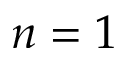Convert formula to latex. <formula><loc_0><loc_0><loc_500><loc_500>n = 1</formula> 